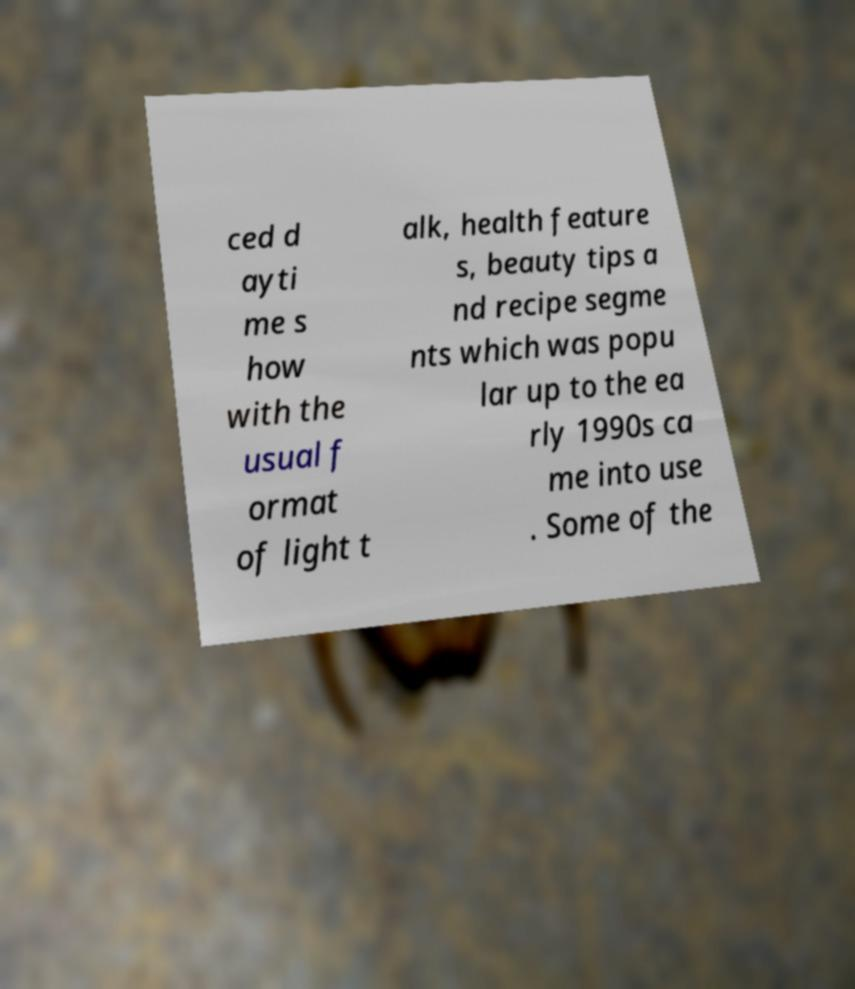For documentation purposes, I need the text within this image transcribed. Could you provide that? ced d ayti me s how with the usual f ormat of light t alk, health feature s, beauty tips a nd recipe segme nts which was popu lar up to the ea rly 1990s ca me into use . Some of the 